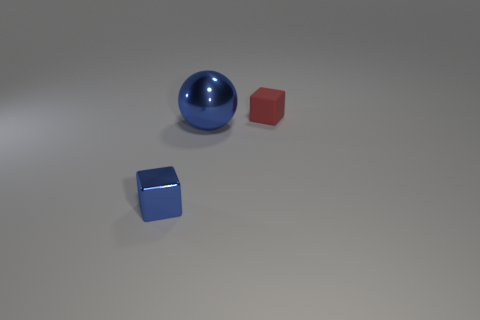What size is the object that is in front of the red object and behind the shiny block?
Provide a succinct answer. Large. There is a blue object right of the small metallic thing; what is its size?
Give a very brief answer. Large. The shiny thing that is on the right side of the tiny cube on the left side of the red thing is what shape?
Provide a short and direct response. Sphere. Does the red object have the same shape as the large thing?
Offer a terse response. No. There is another thing that is the same color as the big metal thing; what material is it?
Your response must be concise. Metal. Do the sphere and the small shiny object have the same color?
Offer a very short reply. Yes. There is a tiny thing that is behind the block that is on the left side of the small red matte object; what number of large blue balls are behind it?
Provide a succinct answer. 0. There is a blue thing that is the same material as the tiny blue cube; what is its shape?
Offer a very short reply. Sphere. What material is the cube right of the blue shiny object on the left side of the blue shiny object behind the tiny metal cube?
Offer a very short reply. Rubber. How many objects are either blocks in front of the matte thing or gray things?
Provide a short and direct response. 1. 